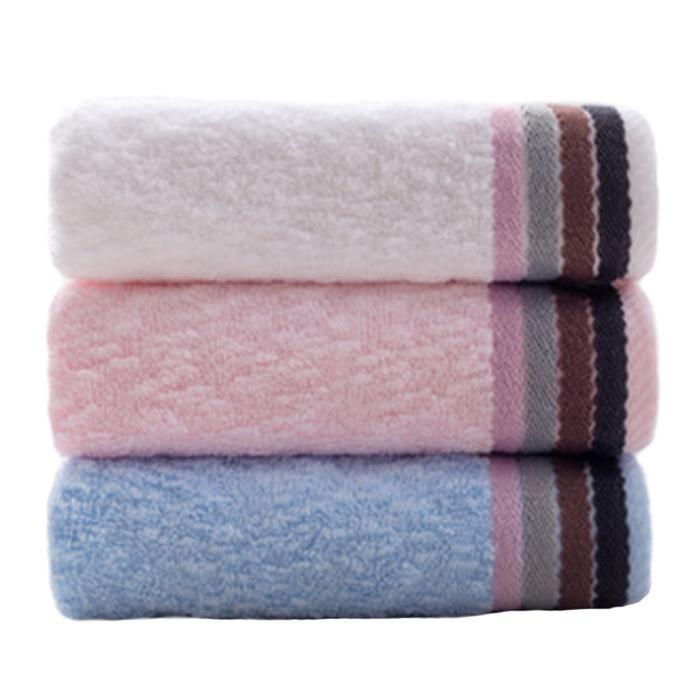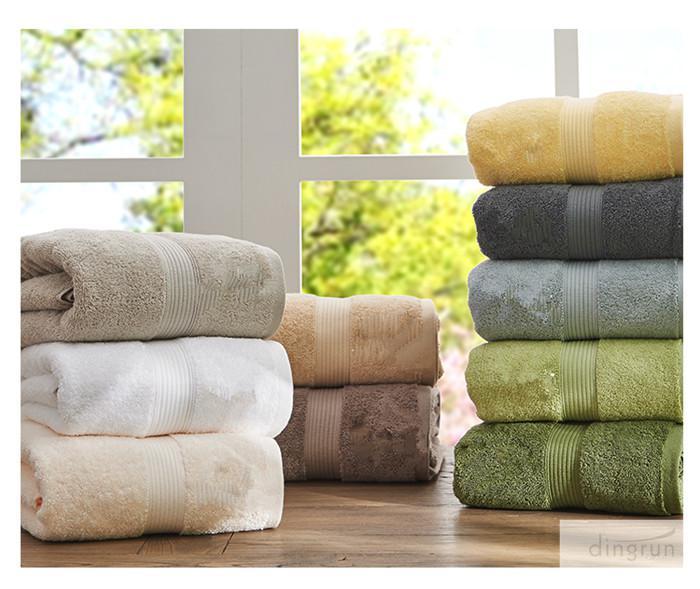The first image is the image on the left, the second image is the image on the right. Analyze the images presented: Is the assertion "In at least one image there is a tower of three folded towels." valid? Answer yes or no. Yes. The first image is the image on the left, the second image is the image on the right. Given the left and right images, does the statement "The left image shows exactly three towels, in navy, white and brown, with gold bands of """"Greek key"""" patterns on the towel's edge." hold true? Answer yes or no. No. 